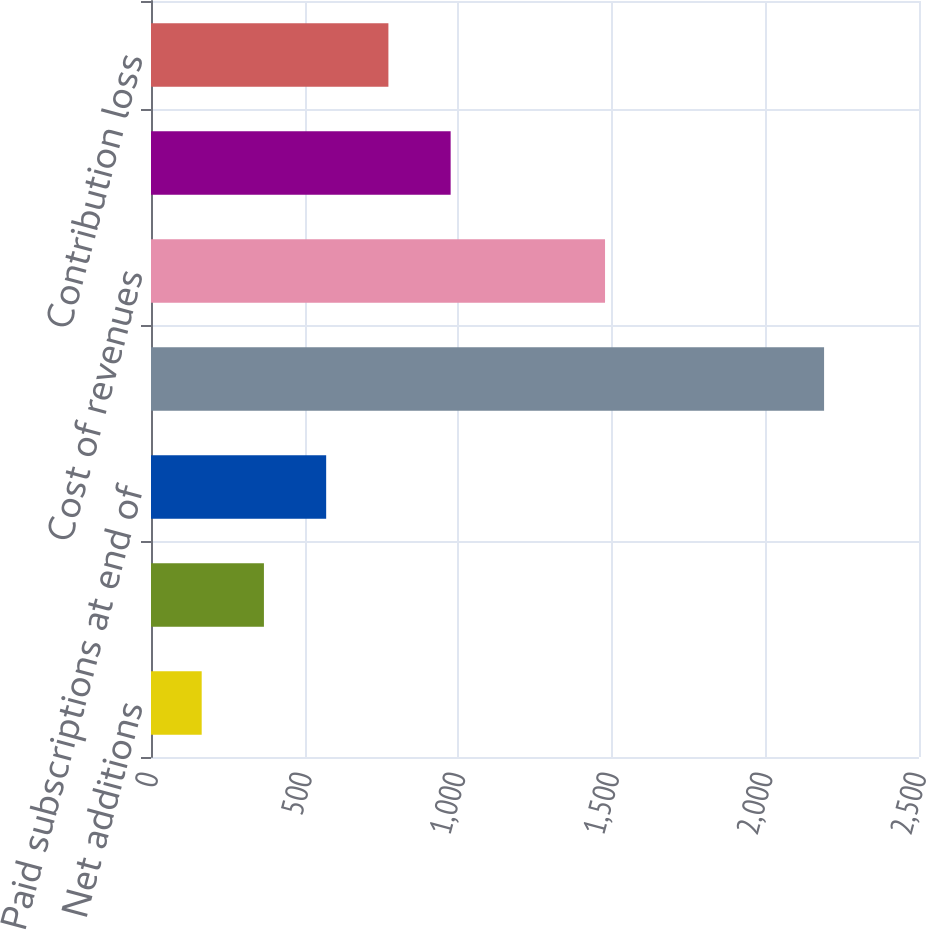<chart> <loc_0><loc_0><loc_500><loc_500><bar_chart><fcel>Net additions<fcel>Subscriptions at end of period<fcel>Paid subscriptions at end of<fcel>Revenues<fcel>Cost of revenues<fcel>Marketing<fcel>Contribution loss<nl><fcel>165<fcel>367.6<fcel>570.2<fcel>2191<fcel>1478<fcel>975.4<fcel>772.8<nl></chart> 